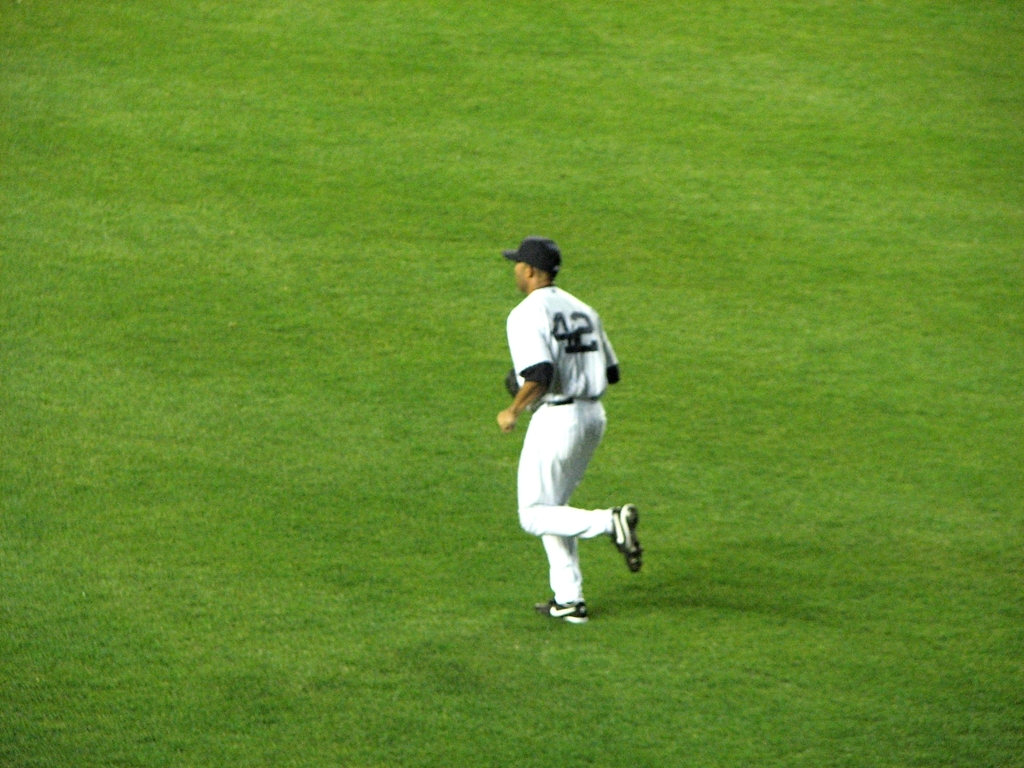What activity is typically performed on this grassland? The grassland in the image is actually a baseball field, which is primarily used for playing baseball games and practice sessions. What can you infer about the time of the event from the lighting in the image? Given the clarity and shadows visible on the field, it appears to be an outdoor event occurring in the evening under artificial stadium lighting. 